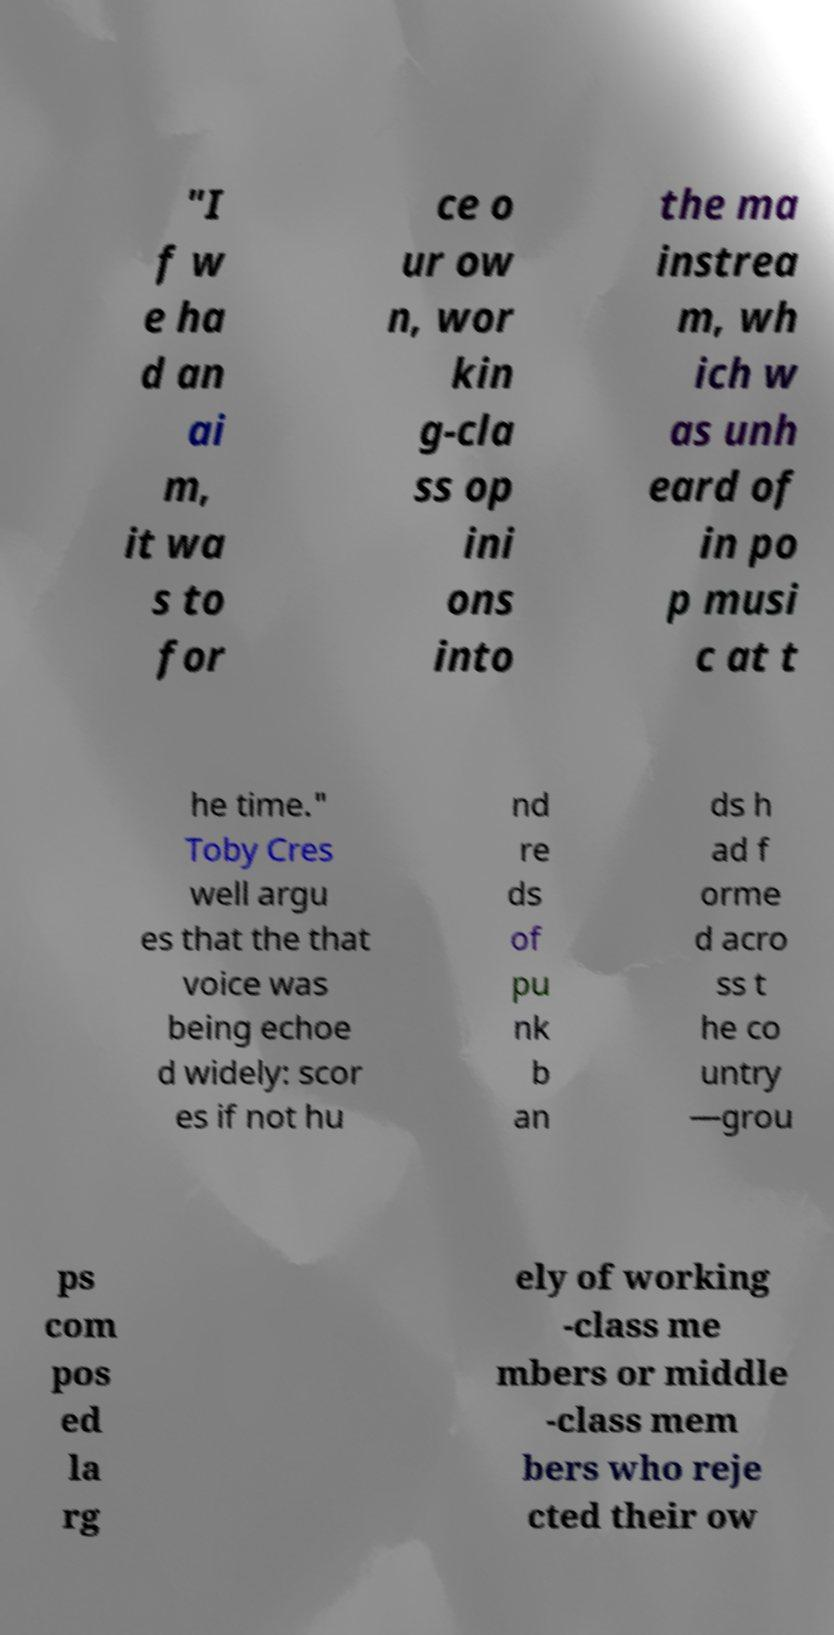Could you assist in decoding the text presented in this image and type it out clearly? "I f w e ha d an ai m, it wa s to for ce o ur ow n, wor kin g-cla ss op ini ons into the ma instrea m, wh ich w as unh eard of in po p musi c at t he time." Toby Cres well argu es that the that voice was being echoe d widely: scor es if not hu nd re ds of pu nk b an ds h ad f orme d acro ss t he co untry —grou ps com pos ed la rg ely of working -class me mbers or middle -class mem bers who reje cted their ow 